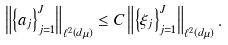Convert formula to latex. <formula><loc_0><loc_0><loc_500><loc_500>\left \| \left \{ a _ { j } \right \} _ { j = 1 } ^ { J } \right \| _ { \ell ^ { 2 } \left ( d \mu \right ) } \leq C \left \| \left \{ \xi _ { j } \right \} _ { j = 1 } ^ { J } \right \| _ { \ell ^ { 2 } \left ( d \mu \right ) } .</formula> 